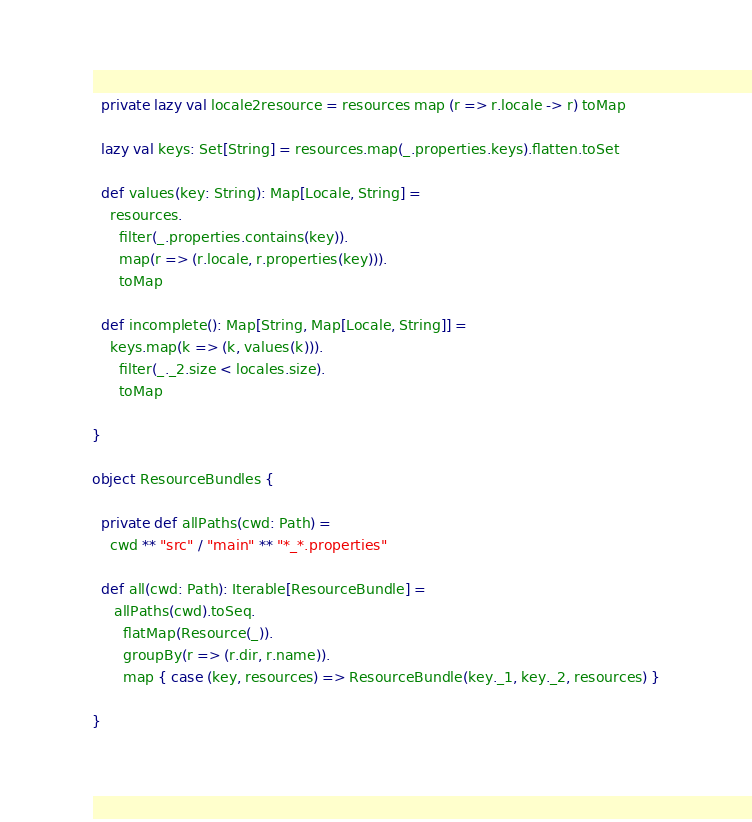Convert code to text. <code><loc_0><loc_0><loc_500><loc_500><_Scala_>  private lazy val locale2resource = resources map (r => r.locale -> r) toMap

  lazy val keys: Set[String] = resources.map(_.properties.keys).flatten.toSet

  def values(key: String): Map[Locale, String] =
    resources.
      filter(_.properties.contains(key)).
      map(r => (r.locale, r.properties(key))).
      toMap
  
  def incomplete(): Map[String, Map[Locale, String]] =
    keys.map(k => (k, values(k))).
      filter(_._2.size < locales.size).
      toMap

}

object ResourceBundles {

  private def allPaths(cwd: Path) =
    cwd ** "src" / "main" ** "*_*.properties"
  
  def all(cwd: Path): Iterable[ResourceBundle] =
     allPaths(cwd).toSeq.
       flatMap(Resource(_)).
       groupBy(r => (r.dir, r.name)).
       map { case (key, resources) => ResourceBundle(key._1, key._2, resources) }
  
}</code> 